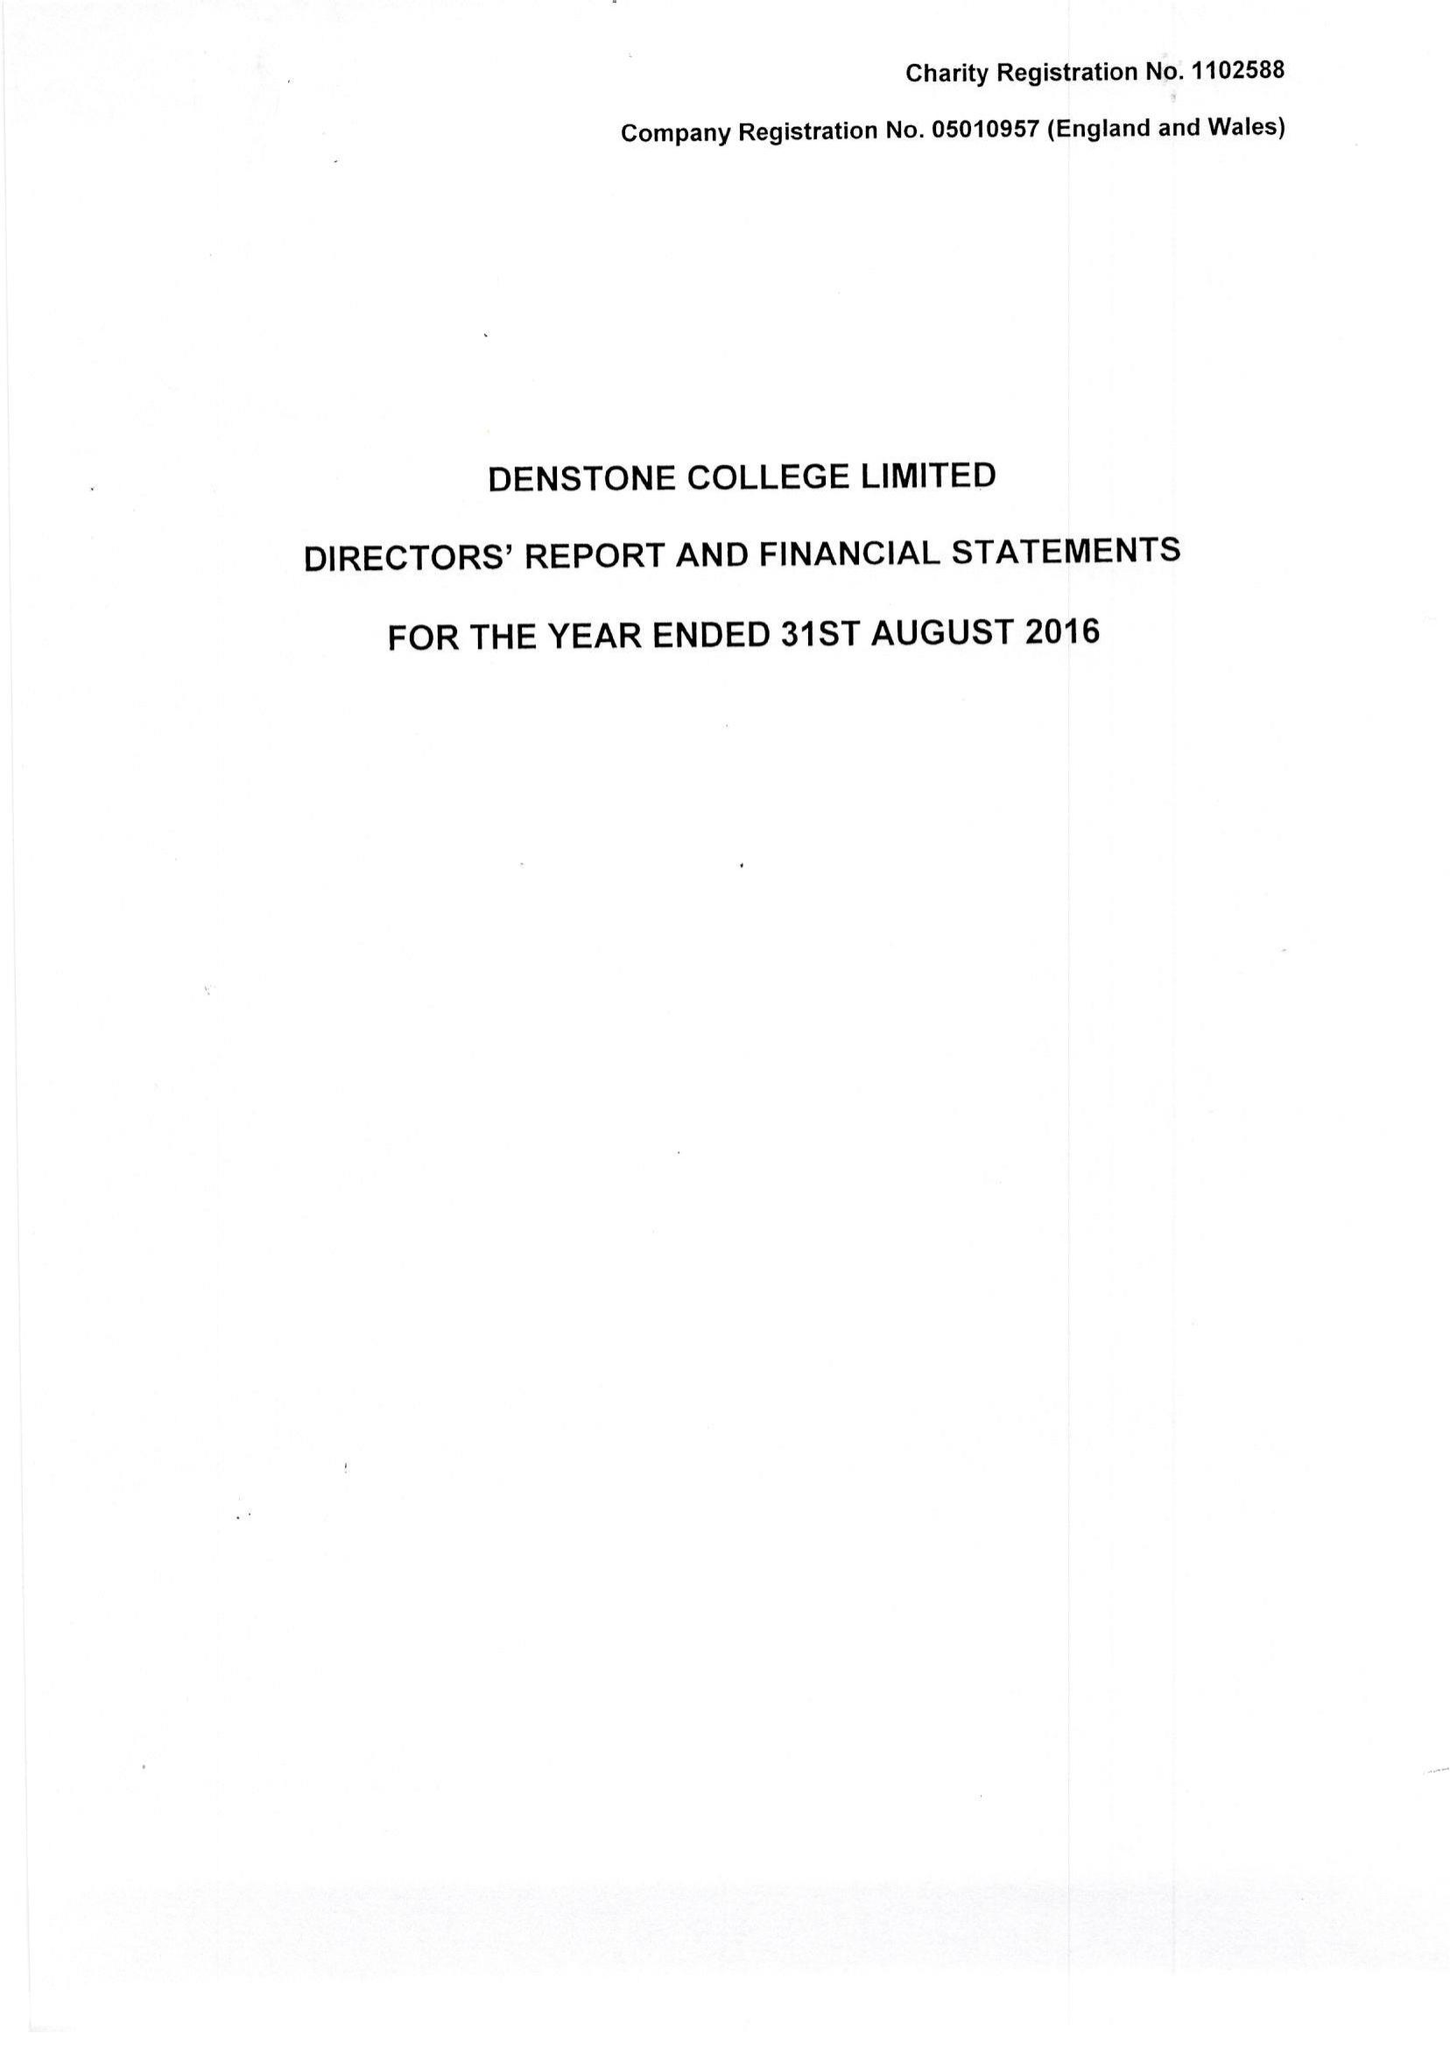What is the value for the spending_annually_in_british_pounds?
Answer the question using a single word or phrase. 9140129.00 